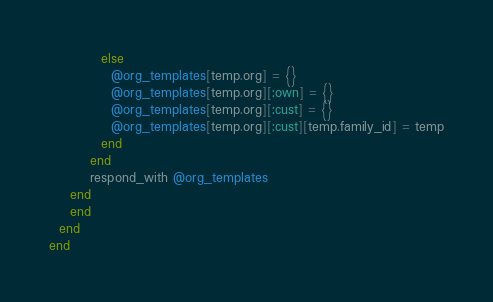Convert code to text. <code><loc_0><loc_0><loc_500><loc_500><_Ruby_>          else
            @org_templates[temp.org] = {}
            @org_templates[temp.org][:own] = {}
            @org_templates[temp.org][:cust] = {}
            @org_templates[temp.org][:cust][temp.family_id] = temp
          end
        end
        respond_with @org_templates
    end
    end
  end
end</code> 